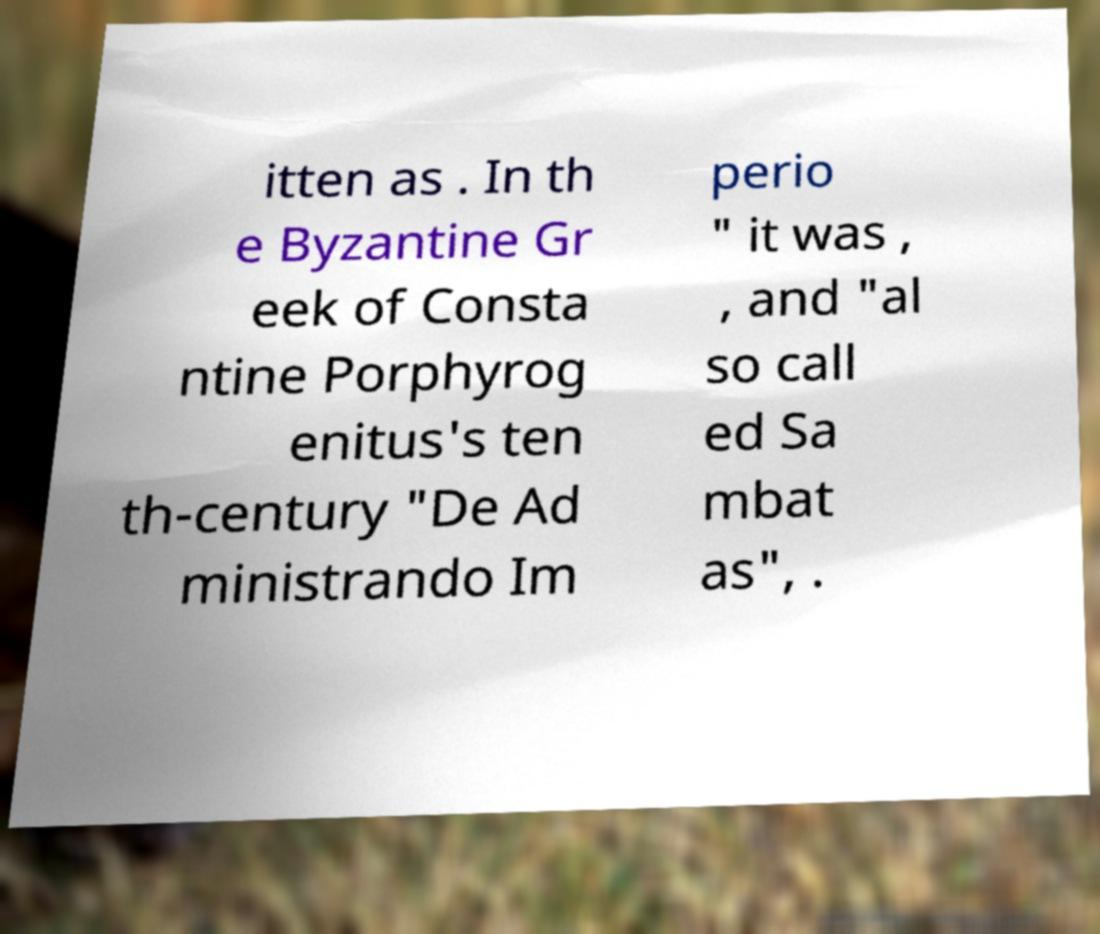What messages or text are displayed in this image? I need them in a readable, typed format. itten as . In th e Byzantine Gr eek of Consta ntine Porphyrog enitus's ten th-century "De Ad ministrando Im perio " it was , , and "al so call ed Sa mbat as", . 